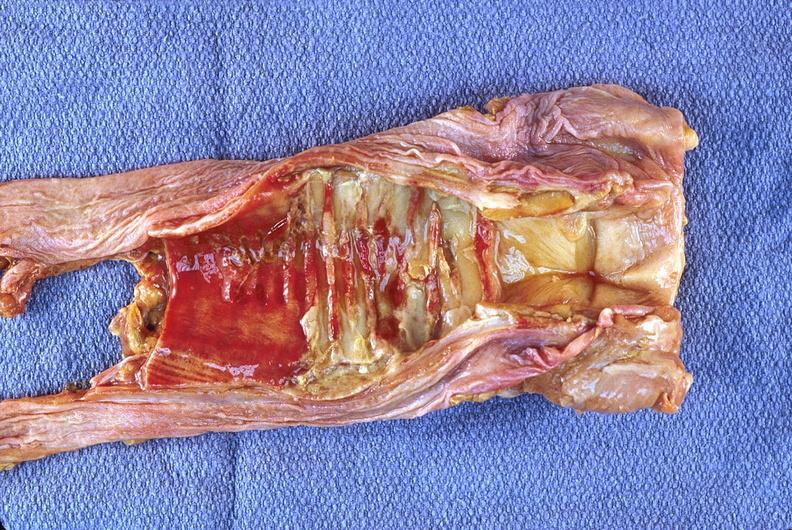where is this?
Answer the question using a single word or phrase. Lung 